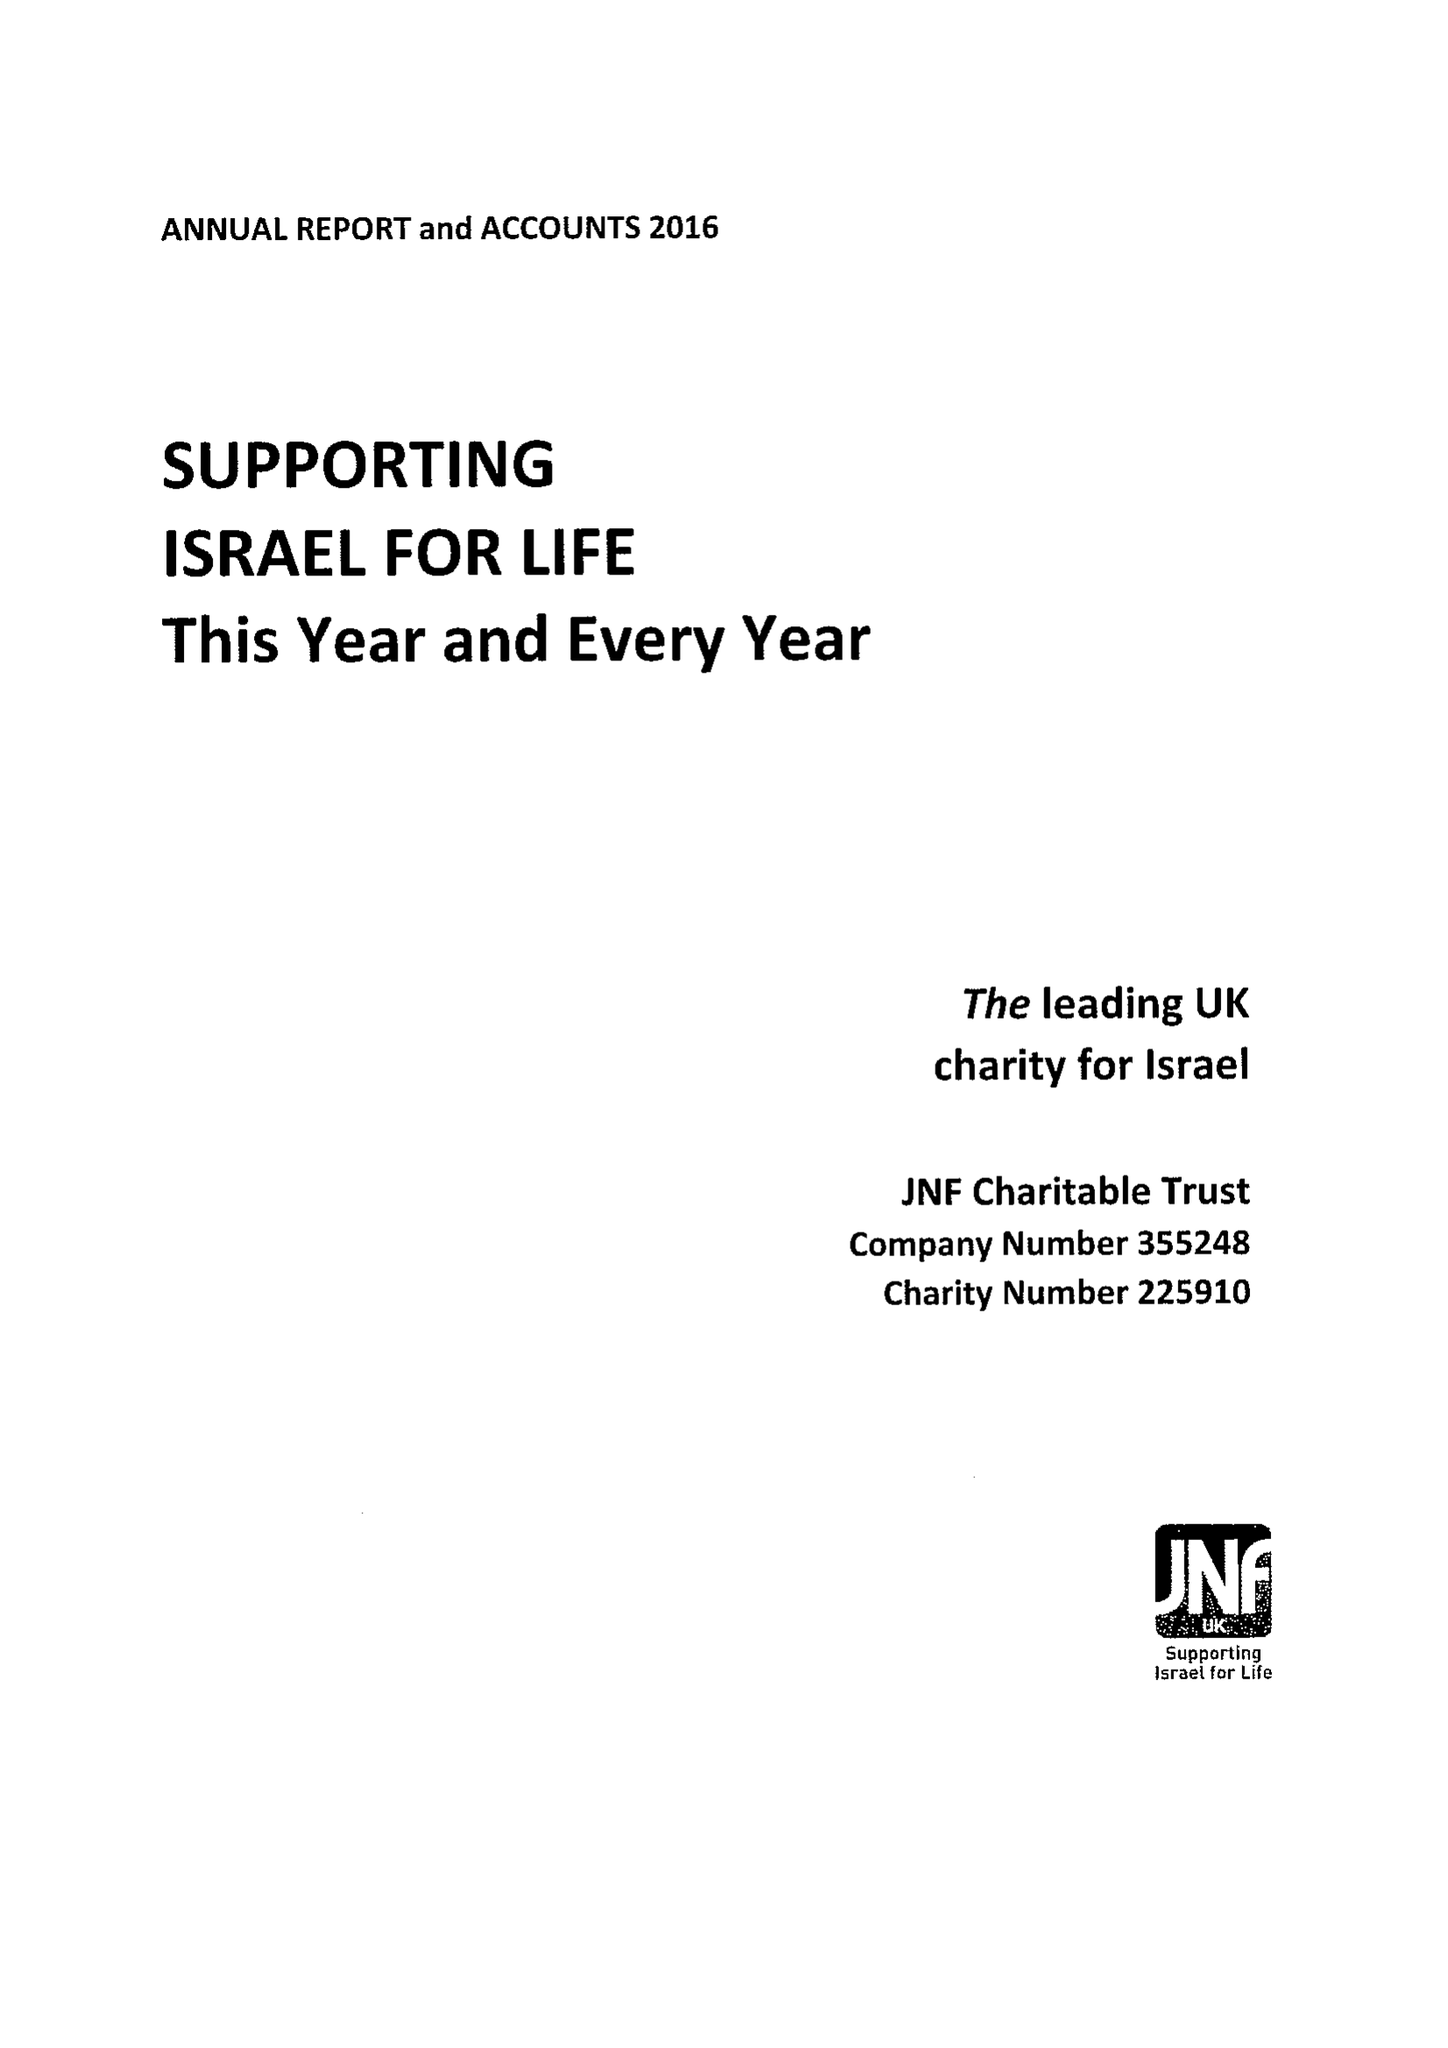What is the value for the report_date?
Answer the question using a single word or phrase. 2016-12-31 